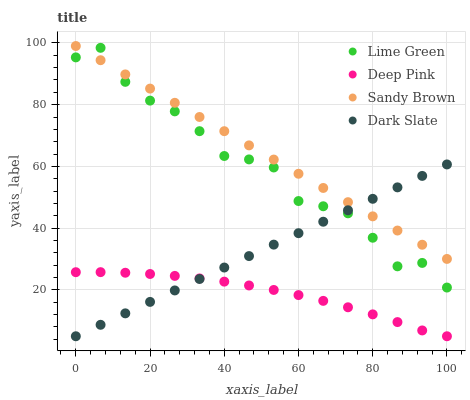Does Deep Pink have the minimum area under the curve?
Answer yes or no. Yes. Does Sandy Brown have the maximum area under the curve?
Answer yes or no. Yes. Does Lime Green have the minimum area under the curve?
Answer yes or no. No. Does Lime Green have the maximum area under the curve?
Answer yes or no. No. Is Dark Slate the smoothest?
Answer yes or no. Yes. Is Lime Green the roughest?
Answer yes or no. Yes. Is Deep Pink the smoothest?
Answer yes or no. No. Is Deep Pink the roughest?
Answer yes or no. No. Does Deep Pink have the lowest value?
Answer yes or no. Yes. Does Lime Green have the lowest value?
Answer yes or no. No. Does Sandy Brown have the highest value?
Answer yes or no. Yes. Does Lime Green have the highest value?
Answer yes or no. No. Is Deep Pink less than Lime Green?
Answer yes or no. Yes. Is Sandy Brown greater than Deep Pink?
Answer yes or no. Yes. Does Sandy Brown intersect Lime Green?
Answer yes or no. Yes. Is Sandy Brown less than Lime Green?
Answer yes or no. No. Is Sandy Brown greater than Lime Green?
Answer yes or no. No. Does Deep Pink intersect Lime Green?
Answer yes or no. No. 